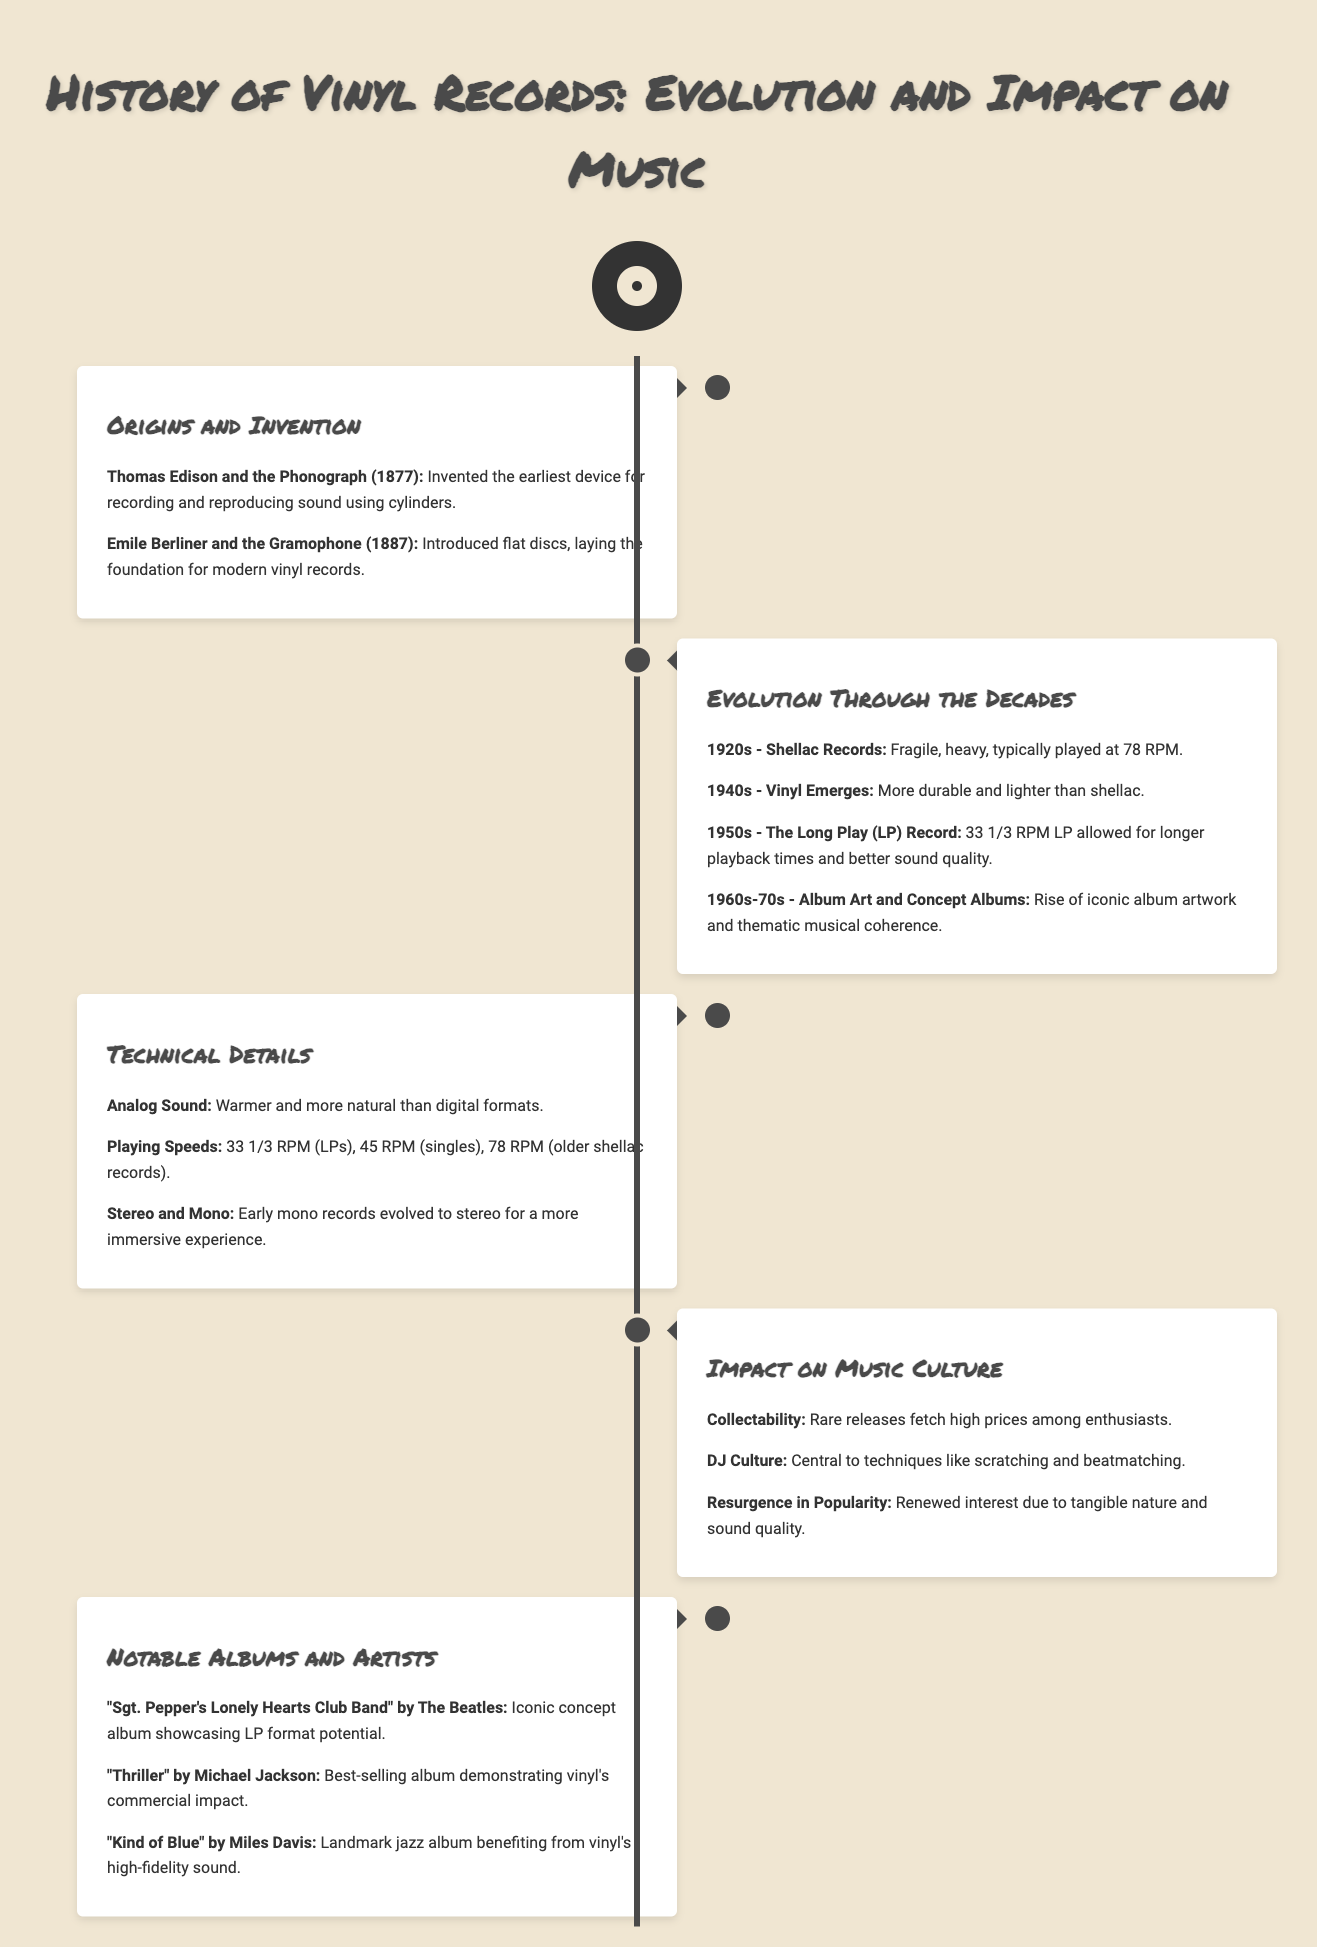What year was the phonograph invented? The phonograph was invented by Thomas Edison in 1877, as mentioned in the Origins and Invention section.
Answer: 1877 Who introduced the flat discs that led to modern vinyl records? Emile Berliner introduced flat discs in 1887, according to the Origins and Invention section.
Answer: Emile Berliner What was the typical speed of shellac records in the 1920s? Shellac records typically played at 78 RPM, as stated in the Evolution Through the Decades section.
Answer: 78 RPM What format emerged in the 1940s that was more durable than shellac? The document mentions that vinyl emerged in the 1940s, replacing shellac.
Answer: Vinyl Which iconic album showcases the LP format potential according to the Notable Albums and Artists section? The album "Sgt. Pepper's Lonely Hearts Club Band" by The Beatles is highlighted for its LP format potential.
Answer: "Sgt. Pepper's Lonely Hearts Club Band" Why is analog sound considered better than digital formats? Analog sound is described as warmer and more natural compared to digital formats, as noted in the Technical Details section.
Answer: Warmer What notable technique in DJ culture is mentioned in the Impact on Music Culture section? Scratching is one of the central techniques in DJ culture mentioned in the document.
Answer: Scratching How did the popularity of vinyl records change over time? The document states that there has been a resurgence in vinyl's popularity due to its tangible nature and sound quality.
Answer: Resurgence What are the common playback speeds of vinyl records? The common playback speeds mentioned are 33 1/3 RPM for LPs, 45 RPM for singles, and 78 RPM for older shellac records.
Answer: 33 1/3 RPM, 45 RPM, 78 RPM 